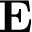<formula> <loc_0><loc_0><loc_500><loc_500>E</formula> 